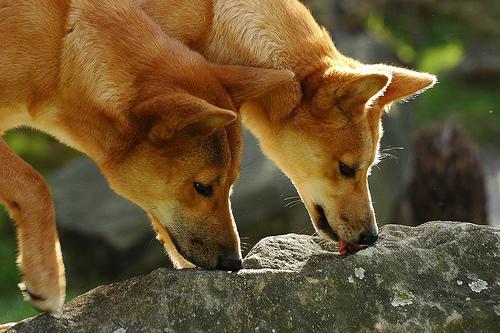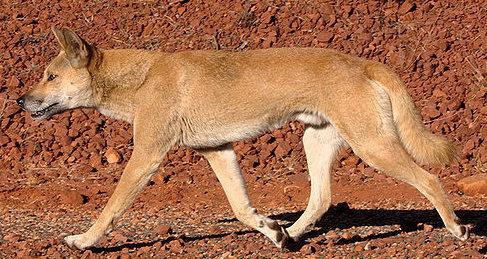The first image is the image on the left, the second image is the image on the right. Assess this claim about the two images: "The left image includes exactly twice as many wild dogs as the right image.". Correct or not? Answer yes or no. Yes. The first image is the image on the left, the second image is the image on the right. Examine the images to the left and right. Is the description "At least one animal is lying down in one of the images." accurate? Answer yes or no. No. 